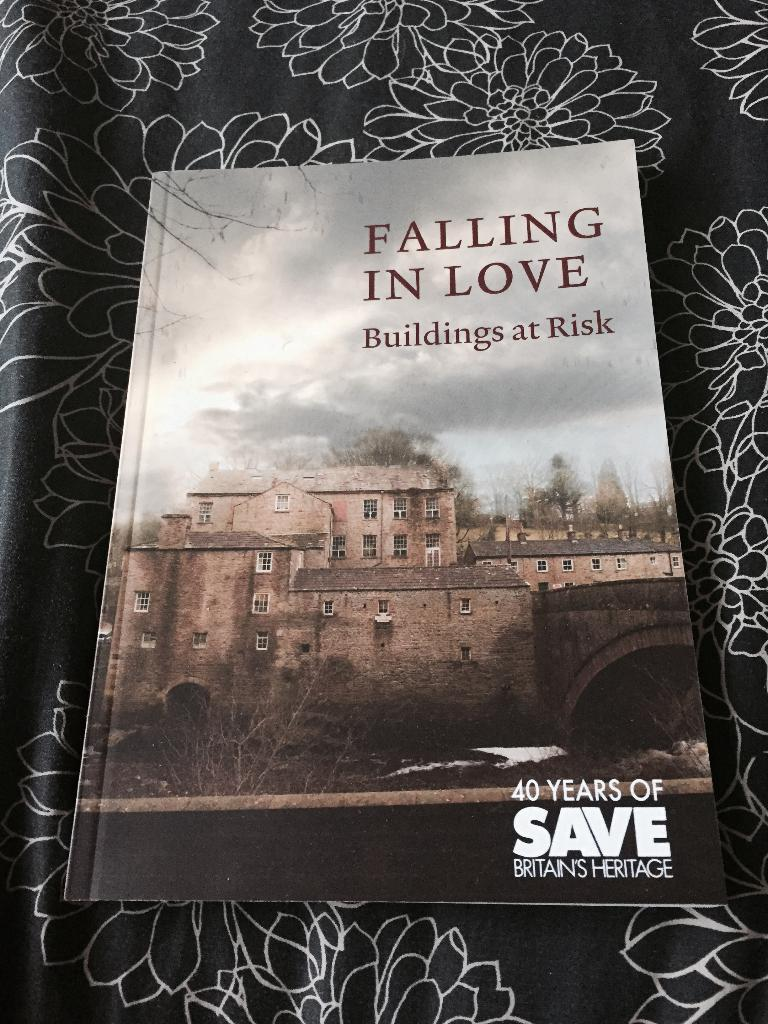<image>
Summarize the visual content of the image. A book titled Falling in Love Buildings at Risk sits on top of a flowered cloth 